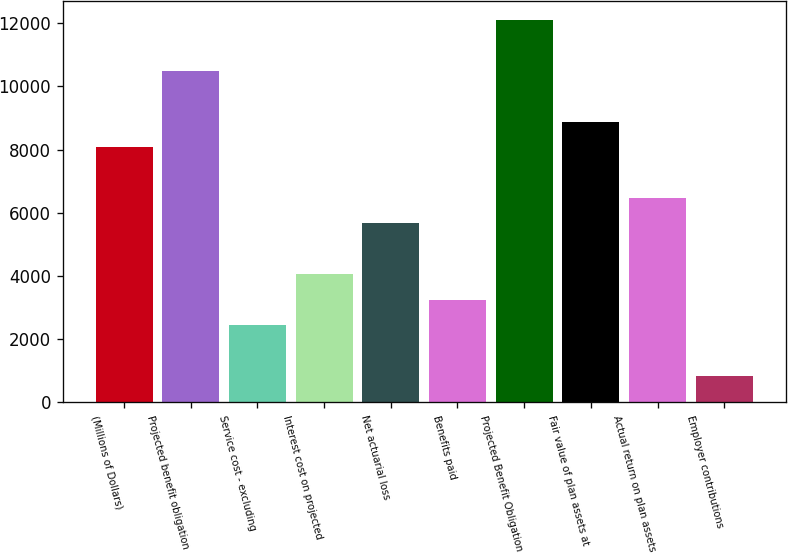Convert chart to OTSL. <chart><loc_0><loc_0><loc_500><loc_500><bar_chart><fcel>(Millions of Dollars)<fcel>Projected benefit obligation<fcel>Service cost - excluding<fcel>Interest cost on projected<fcel>Net actuarial loss<fcel>Benefits paid<fcel>Projected Benefit Obligation<fcel>Fair value of plan assets at<fcel>Actual return on plan assets<fcel>Employer contributions<nl><fcel>8083<fcel>10498.6<fcel>2446.6<fcel>4057<fcel>5667.4<fcel>3251.8<fcel>12109<fcel>8888.2<fcel>6472.6<fcel>836.2<nl></chart> 